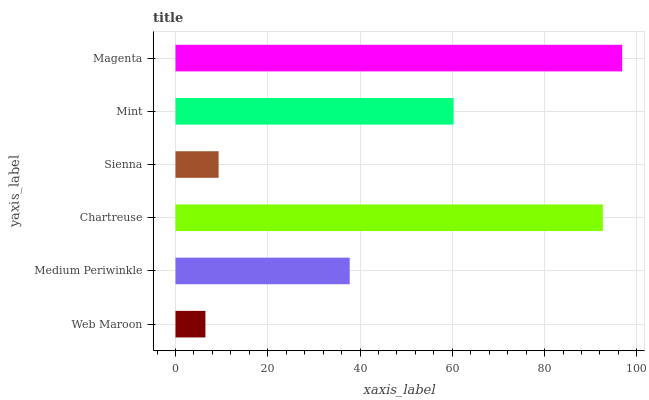Is Web Maroon the minimum?
Answer yes or no. Yes. Is Magenta the maximum?
Answer yes or no. Yes. Is Medium Periwinkle the minimum?
Answer yes or no. No. Is Medium Periwinkle the maximum?
Answer yes or no. No. Is Medium Periwinkle greater than Web Maroon?
Answer yes or no. Yes. Is Web Maroon less than Medium Periwinkle?
Answer yes or no. Yes. Is Web Maroon greater than Medium Periwinkle?
Answer yes or no. No. Is Medium Periwinkle less than Web Maroon?
Answer yes or no. No. Is Mint the high median?
Answer yes or no. Yes. Is Medium Periwinkle the low median?
Answer yes or no. Yes. Is Magenta the high median?
Answer yes or no. No. Is Mint the low median?
Answer yes or no. No. 